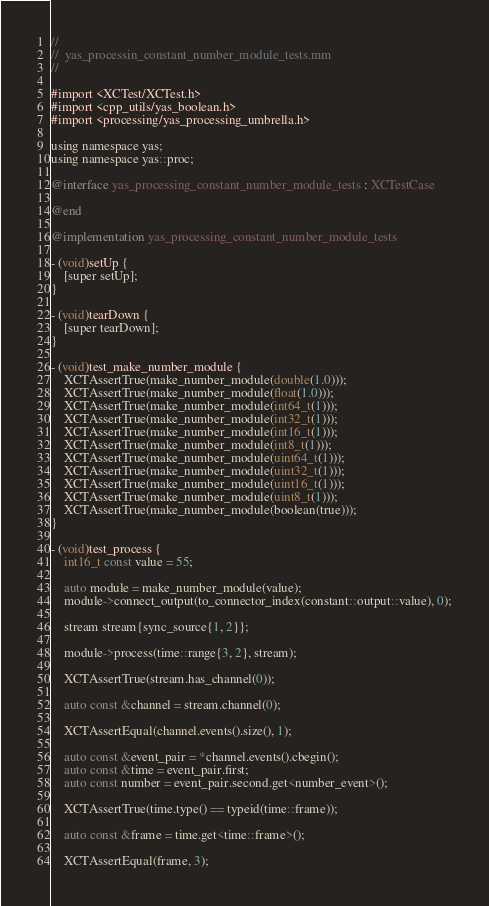<code> <loc_0><loc_0><loc_500><loc_500><_ObjectiveC_>//
//  yas_processin_constant_number_module_tests.mm
//

#import <XCTest/XCTest.h>
#import <cpp_utils/yas_boolean.h>
#import <processing/yas_processing_umbrella.h>

using namespace yas;
using namespace yas::proc;

@interface yas_processing_constant_number_module_tests : XCTestCase

@end

@implementation yas_processing_constant_number_module_tests

- (void)setUp {
    [super setUp];
}

- (void)tearDown {
    [super tearDown];
}

- (void)test_make_number_module {
    XCTAssertTrue(make_number_module(double(1.0)));
    XCTAssertTrue(make_number_module(float(1.0)));
    XCTAssertTrue(make_number_module(int64_t(1)));
    XCTAssertTrue(make_number_module(int32_t(1)));
    XCTAssertTrue(make_number_module(int16_t(1)));
    XCTAssertTrue(make_number_module(int8_t(1)));
    XCTAssertTrue(make_number_module(uint64_t(1)));
    XCTAssertTrue(make_number_module(uint32_t(1)));
    XCTAssertTrue(make_number_module(uint16_t(1)));
    XCTAssertTrue(make_number_module(uint8_t(1)));
    XCTAssertTrue(make_number_module(boolean(true)));
}

- (void)test_process {
    int16_t const value = 55;

    auto module = make_number_module(value);
    module->connect_output(to_connector_index(constant::output::value), 0);

    stream stream{sync_source{1, 2}};

    module->process(time::range{3, 2}, stream);

    XCTAssertTrue(stream.has_channel(0));

    auto const &channel = stream.channel(0);

    XCTAssertEqual(channel.events().size(), 1);

    auto const &event_pair = *channel.events().cbegin();
    auto const &time = event_pair.first;
    auto const number = event_pair.second.get<number_event>();

    XCTAssertTrue(time.type() == typeid(time::frame));

    auto const &frame = time.get<time::frame>();

    XCTAssertEqual(frame, 3);</code> 